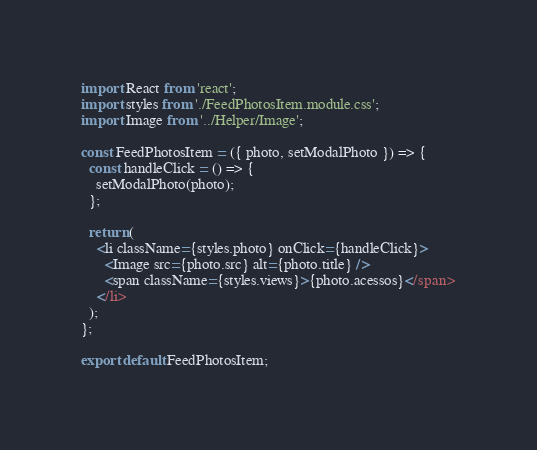Convert code to text. <code><loc_0><loc_0><loc_500><loc_500><_JavaScript_>import React from 'react';
import styles from './FeedPhotosItem.module.css';
import Image from '../Helper/Image';

const FeedPhotosItem = ({ photo, setModalPhoto }) => {
  const handleClick = () => {
    setModalPhoto(photo);
  };

  return (
    <li className={styles.photo} onClick={handleClick}>
      <Image src={photo.src} alt={photo.title} />
      <span className={styles.views}>{photo.acessos}</span>
    </li>
  );
};

export default FeedPhotosItem;
</code> 